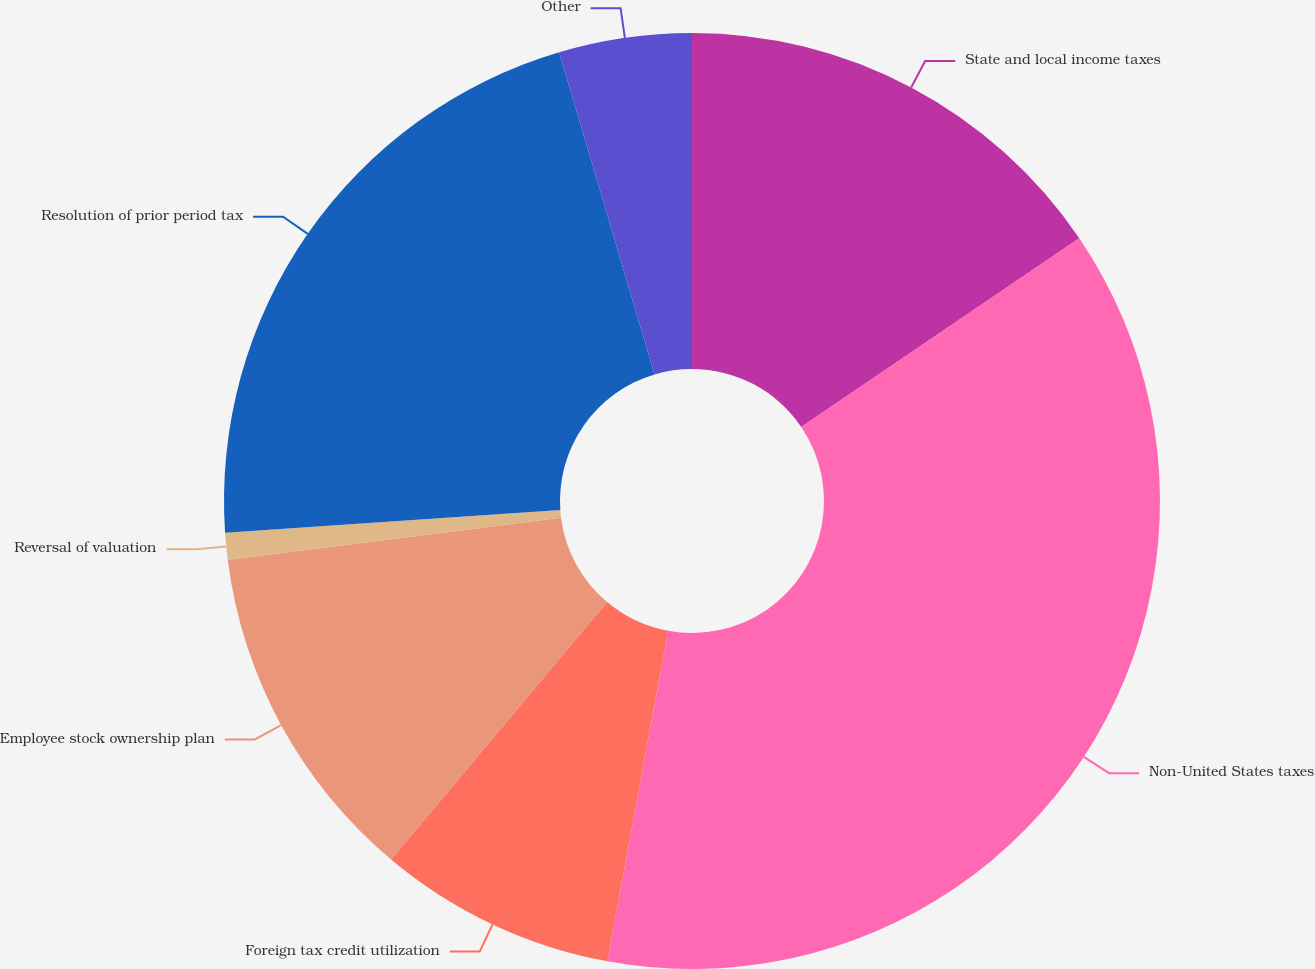Convert chart to OTSL. <chart><loc_0><loc_0><loc_500><loc_500><pie_chart><fcel>State and local income taxes<fcel>Non-United States taxes<fcel>Foreign tax credit utilization<fcel>Employee stock ownership plan<fcel>Reversal of valuation<fcel>Resolution of prior period tax<fcel>Other<nl><fcel>15.51%<fcel>37.38%<fcel>8.22%<fcel>11.87%<fcel>0.93%<fcel>21.5%<fcel>4.58%<nl></chart> 